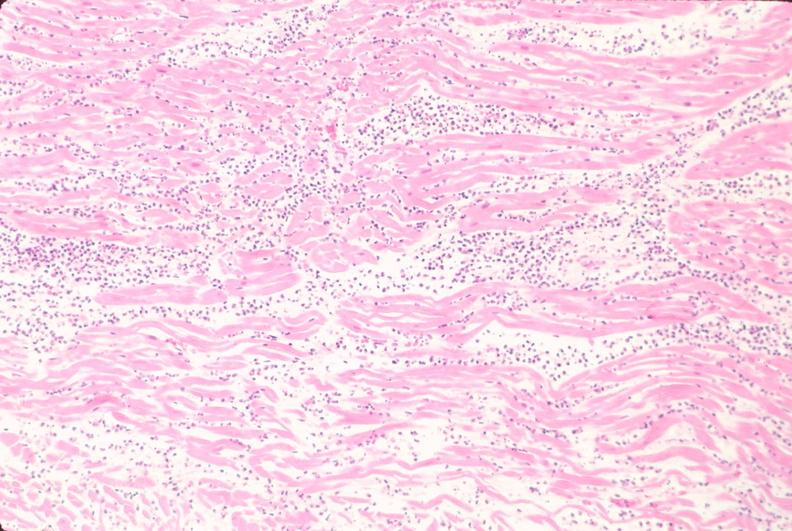what does this image show?
Answer the question using a single word or phrase. Heart 